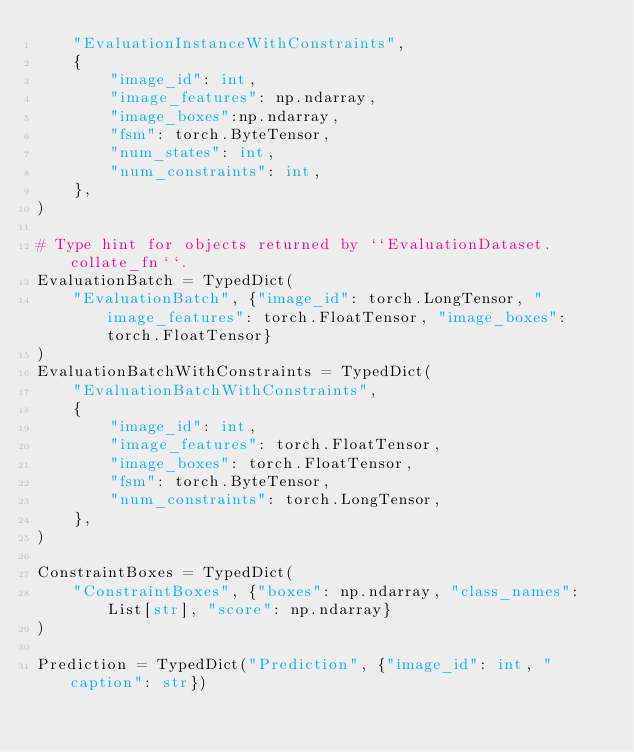<code> <loc_0><loc_0><loc_500><loc_500><_Python_>    "EvaluationInstanceWithConstraints",
    {
        "image_id": int,
        "image_features": np.ndarray,
        "image_boxes":np.ndarray,
        "fsm": torch.ByteTensor,
        "num_states": int,
        "num_constraints": int,
    },
)

# Type hint for objects returned by ``EvaluationDataset.collate_fn``.
EvaluationBatch = TypedDict(
    "EvaluationBatch", {"image_id": torch.LongTensor, "image_features": torch.FloatTensor, "image_boxes":torch.FloatTensor}
)
EvaluationBatchWithConstraints = TypedDict(
    "EvaluationBatchWithConstraints",
    {
        "image_id": int,
        "image_features": torch.FloatTensor,
        "image_boxes": torch.FloatTensor,
        "fsm": torch.ByteTensor,
        "num_constraints": torch.LongTensor,
    },
)

ConstraintBoxes = TypedDict(
    "ConstraintBoxes", {"boxes": np.ndarray, "class_names": List[str], "score": np.ndarray}
)

Prediction = TypedDict("Prediction", {"image_id": int, "caption": str})
</code> 